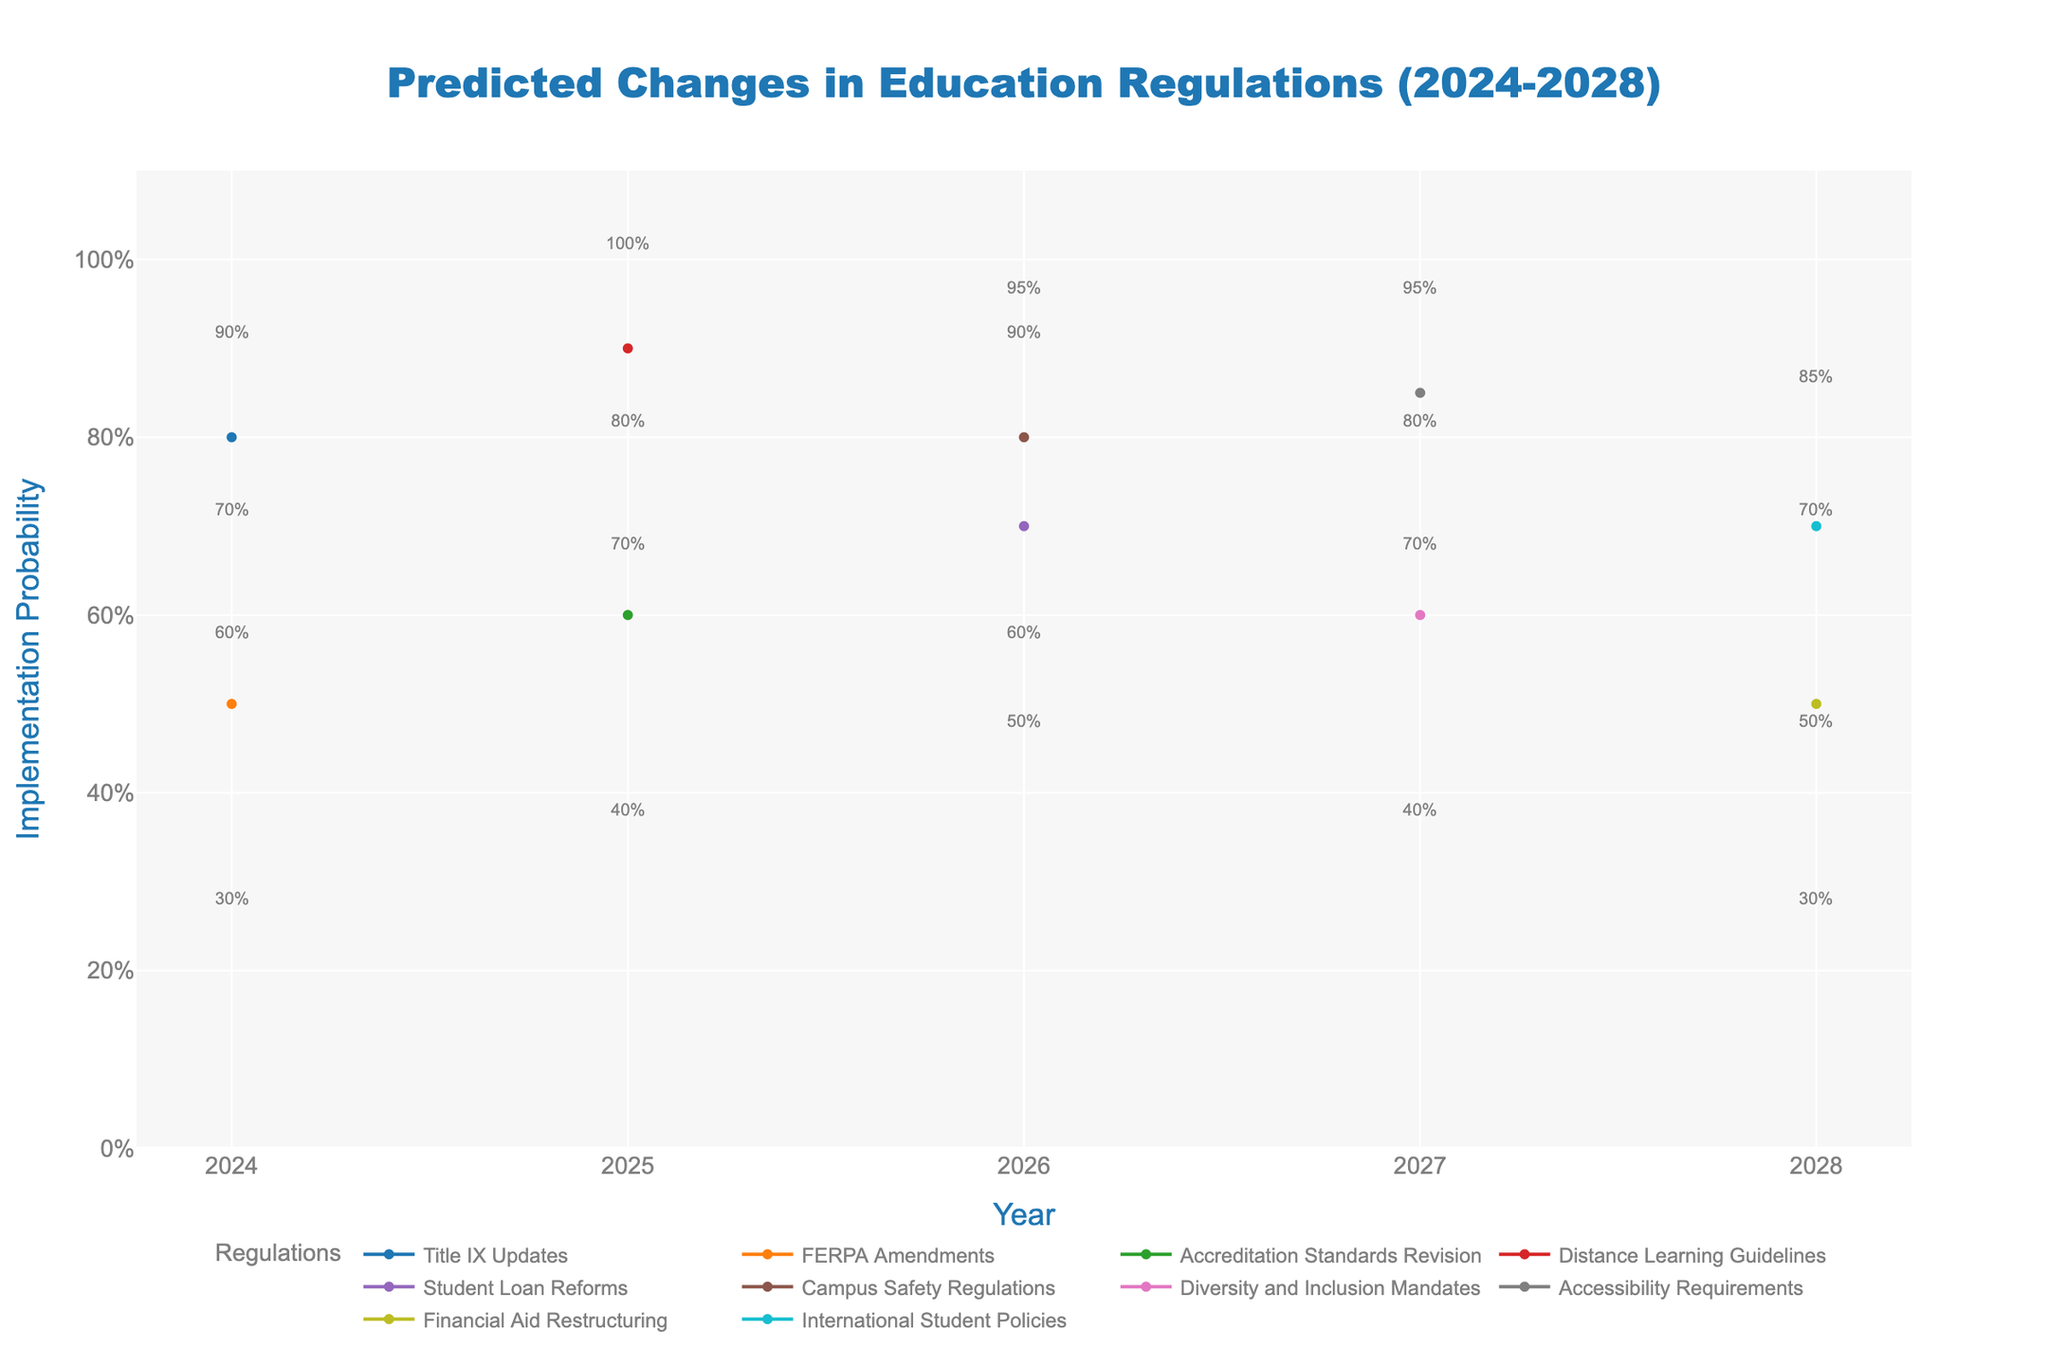What's the predicted mid estimate for the implementation probability of Title IX Updates in 2024? According to the figure, the mid estimate for the implementation probability of Title IX Updates in 2024 is directly labeled.
Answer: 0.8 Which years have a mid estimate for FERPA Amendments? By referring to the x-axis and the scatter points for FERPA Amendments, we see it only appears in 2024.
Answer: 2024 Compare the high estimates of Distance Learning Guidelines and Student Loan Reforms. Which one is expected to be implemented more confidently? The high estimates for these regulations are shown in the shaded areas. For Distance Learning Guidelines in 2025, it is 1.0, while for Student Loan Reforms in 2026, it is 0.9.
Answer: Distance Learning Guidelines What's the range of implementation probability for Campus Safety Regulations in 2026? The shaded area between the low and high estimates indicates the range. For Campus Safety Regulations in 2026, these estimates are 0.6 and 0.95 respectively.
Answer: 0.6 to 0.95 What is the overall trend in implementation probabilities for Accessibility Requirements from the given data? Accessibility Requirements appear only in 2027. The mid estimate is 0.85, with the low being 0.7, and the high being 0.95, making it strongly likely to be implemented.
Answer: Strongly likely Which regulation has the highest mid estimate in 2025? By reviewing the mid estimates for 2025, we see Distance Learning Guidelines (0.9) surpass Accreditation Standards Revision (0.6).
Answer: Distance Learning Guidelines Is the implementation probability of Financial Aid Restructuring higher in 2028 than the mid estimate of Student Loan Reforms in 2026? We compare the mid estimates: Financial Aid Restructuring in 2028 is 0.5, while Student Loan Reforms in 2026 is 0.7.
Answer: No How does the confidence interval width for the Accreditation Standards Revision in 2025 compare to that for FERPA Amendments in 2024? The intervals are seen in the shaded areas: for Accreditation Standards Revision (0.4 to 0.8), the width is 0.4; for FERPA Amendments (0.3 to 0.7), the width is also 0.4.
Answer: Equal 